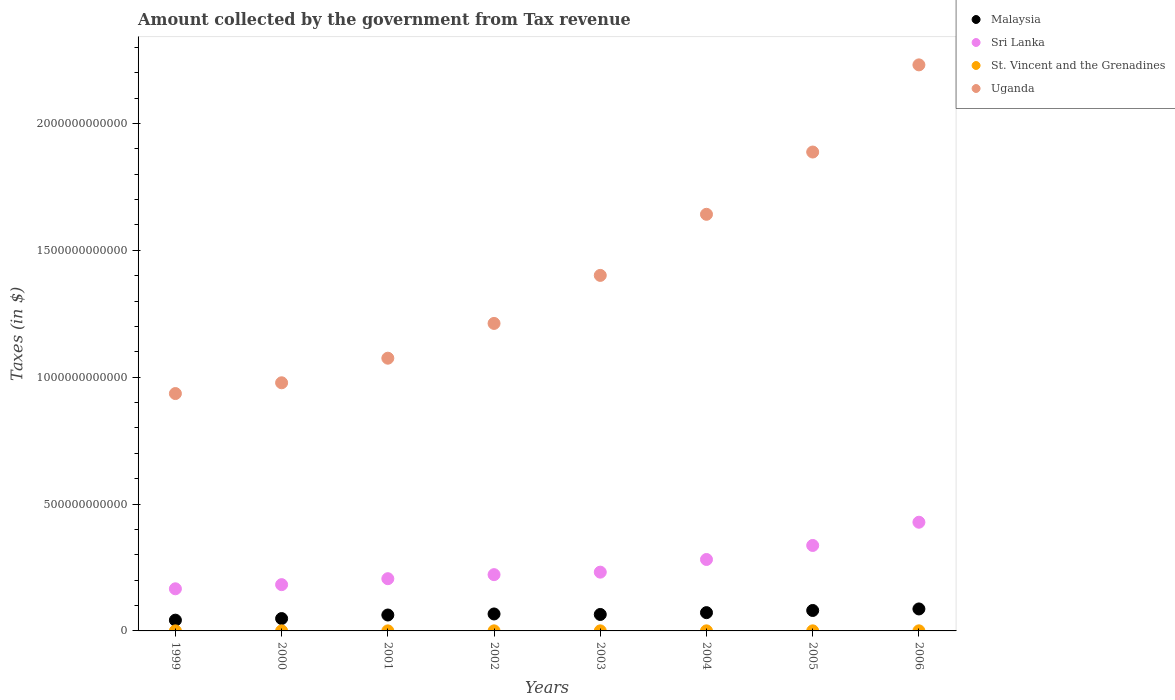What is the amount collected by the government from tax revenue in Uganda in 2006?
Make the answer very short. 2.23e+12. Across all years, what is the maximum amount collected by the government from tax revenue in Sri Lanka?
Your response must be concise. 4.28e+11. Across all years, what is the minimum amount collected by the government from tax revenue in Uganda?
Your answer should be very brief. 9.36e+11. In which year was the amount collected by the government from tax revenue in Uganda maximum?
Offer a very short reply. 2006. In which year was the amount collected by the government from tax revenue in Malaysia minimum?
Keep it short and to the point. 1999. What is the total amount collected by the government from tax revenue in Uganda in the graph?
Make the answer very short. 1.14e+13. What is the difference between the amount collected by the government from tax revenue in Sri Lanka in 1999 and that in 2001?
Provide a succinct answer. -3.98e+1. What is the difference between the amount collected by the government from tax revenue in St. Vincent and the Grenadines in 2006 and the amount collected by the government from tax revenue in Sri Lanka in 2001?
Provide a short and direct response. -2.05e+11. What is the average amount collected by the government from tax revenue in Sri Lanka per year?
Offer a very short reply. 2.57e+11. In the year 2006, what is the difference between the amount collected by the government from tax revenue in St. Vincent and the Grenadines and amount collected by the government from tax revenue in Uganda?
Give a very brief answer. -2.23e+12. What is the ratio of the amount collected by the government from tax revenue in Malaysia in 2002 to that in 2005?
Ensure brevity in your answer.  0.83. Is the amount collected by the government from tax revenue in Sri Lanka in 1999 less than that in 2006?
Offer a very short reply. Yes. What is the difference between the highest and the second highest amount collected by the government from tax revenue in Sri Lanka?
Make the answer very short. 9.16e+1. What is the difference between the highest and the lowest amount collected by the government from tax revenue in Sri Lanka?
Offer a very short reply. 2.62e+11. In how many years, is the amount collected by the government from tax revenue in Uganda greater than the average amount collected by the government from tax revenue in Uganda taken over all years?
Make the answer very short. 3. Is the sum of the amount collected by the government from tax revenue in Uganda in 2001 and 2002 greater than the maximum amount collected by the government from tax revenue in St. Vincent and the Grenadines across all years?
Offer a terse response. Yes. Is it the case that in every year, the sum of the amount collected by the government from tax revenue in Uganda and amount collected by the government from tax revenue in St. Vincent and the Grenadines  is greater than the amount collected by the government from tax revenue in Sri Lanka?
Make the answer very short. Yes. Is the amount collected by the government from tax revenue in St. Vincent and the Grenadines strictly less than the amount collected by the government from tax revenue in Uganda over the years?
Provide a succinct answer. Yes. What is the difference between two consecutive major ticks on the Y-axis?
Keep it short and to the point. 5.00e+11. Are the values on the major ticks of Y-axis written in scientific E-notation?
Provide a succinct answer. No. What is the title of the graph?
Offer a terse response. Amount collected by the government from Tax revenue. What is the label or title of the X-axis?
Provide a short and direct response. Years. What is the label or title of the Y-axis?
Offer a very short reply. Taxes (in $). What is the Taxes (in $) of Malaysia in 1999?
Offer a very short reply. 4.24e+1. What is the Taxes (in $) of Sri Lanka in 1999?
Your answer should be very brief. 1.66e+11. What is the Taxes (in $) of St. Vincent and the Grenadines in 1999?
Your answer should be very brief. 2.18e+08. What is the Taxes (in $) of Uganda in 1999?
Provide a short and direct response. 9.36e+11. What is the Taxes (in $) of Malaysia in 2000?
Provide a short and direct response. 4.87e+1. What is the Taxes (in $) in Sri Lanka in 2000?
Provide a short and direct response. 1.82e+11. What is the Taxes (in $) of St. Vincent and the Grenadines in 2000?
Offer a terse response. 2.28e+08. What is the Taxes (in $) of Uganda in 2000?
Keep it short and to the point. 9.78e+11. What is the Taxes (in $) in Malaysia in 2001?
Your answer should be compact. 6.27e+1. What is the Taxes (in $) of Sri Lanka in 2001?
Give a very brief answer. 2.06e+11. What is the Taxes (in $) of St. Vincent and the Grenadines in 2001?
Provide a short and direct response. 2.42e+08. What is the Taxes (in $) in Uganda in 2001?
Your answer should be compact. 1.07e+12. What is the Taxes (in $) of Malaysia in 2002?
Make the answer very short. 6.69e+1. What is the Taxes (in $) in Sri Lanka in 2002?
Ensure brevity in your answer.  2.22e+11. What is the Taxes (in $) in St. Vincent and the Grenadines in 2002?
Provide a succinct answer. 2.73e+08. What is the Taxes (in $) of Uganda in 2002?
Provide a succinct answer. 1.21e+12. What is the Taxes (in $) of Malaysia in 2003?
Your answer should be very brief. 6.49e+1. What is the Taxes (in $) in Sri Lanka in 2003?
Keep it short and to the point. 2.32e+11. What is the Taxes (in $) of St. Vincent and the Grenadines in 2003?
Provide a short and direct response. 2.72e+08. What is the Taxes (in $) in Uganda in 2003?
Offer a very short reply. 1.40e+12. What is the Taxes (in $) of Malaysia in 2004?
Your answer should be very brief. 7.21e+1. What is the Taxes (in $) in Sri Lanka in 2004?
Provide a succinct answer. 2.82e+11. What is the Taxes (in $) of St. Vincent and the Grenadines in 2004?
Provide a succinct answer. 2.91e+08. What is the Taxes (in $) in Uganda in 2004?
Ensure brevity in your answer.  1.64e+12. What is the Taxes (in $) of Malaysia in 2005?
Provide a succinct answer. 8.06e+1. What is the Taxes (in $) of Sri Lanka in 2005?
Your answer should be compact. 3.37e+11. What is the Taxes (in $) of St. Vincent and the Grenadines in 2005?
Keep it short and to the point. 3.05e+08. What is the Taxes (in $) in Uganda in 2005?
Keep it short and to the point. 1.89e+12. What is the Taxes (in $) of Malaysia in 2006?
Your answer should be very brief. 8.66e+1. What is the Taxes (in $) in Sri Lanka in 2006?
Offer a very short reply. 4.28e+11. What is the Taxes (in $) in St. Vincent and the Grenadines in 2006?
Give a very brief answer. 3.63e+08. What is the Taxes (in $) in Uganda in 2006?
Offer a terse response. 2.23e+12. Across all years, what is the maximum Taxes (in $) of Malaysia?
Offer a very short reply. 8.66e+1. Across all years, what is the maximum Taxes (in $) in Sri Lanka?
Provide a short and direct response. 4.28e+11. Across all years, what is the maximum Taxes (in $) of St. Vincent and the Grenadines?
Your answer should be compact. 3.63e+08. Across all years, what is the maximum Taxes (in $) of Uganda?
Your answer should be very brief. 2.23e+12. Across all years, what is the minimum Taxes (in $) in Malaysia?
Keep it short and to the point. 4.24e+1. Across all years, what is the minimum Taxes (in $) of Sri Lanka?
Keep it short and to the point. 1.66e+11. Across all years, what is the minimum Taxes (in $) of St. Vincent and the Grenadines?
Your answer should be compact. 2.18e+08. Across all years, what is the minimum Taxes (in $) in Uganda?
Your answer should be very brief. 9.36e+11. What is the total Taxes (in $) in Malaysia in the graph?
Your response must be concise. 5.25e+11. What is the total Taxes (in $) of Sri Lanka in the graph?
Offer a terse response. 2.05e+12. What is the total Taxes (in $) of St. Vincent and the Grenadines in the graph?
Offer a terse response. 2.19e+09. What is the total Taxes (in $) of Uganda in the graph?
Your answer should be compact. 1.14e+13. What is the difference between the Taxes (in $) of Malaysia in 1999 and that in 2000?
Keep it short and to the point. -6.32e+09. What is the difference between the Taxes (in $) of Sri Lanka in 1999 and that in 2000?
Your answer should be compact. -1.64e+1. What is the difference between the Taxes (in $) of St. Vincent and the Grenadines in 1999 and that in 2000?
Give a very brief answer. -9.30e+06. What is the difference between the Taxes (in $) in Uganda in 1999 and that in 2000?
Make the answer very short. -4.24e+1. What is the difference between the Taxes (in $) of Malaysia in 1999 and that in 2001?
Offer a terse response. -2.04e+1. What is the difference between the Taxes (in $) of Sri Lanka in 1999 and that in 2001?
Offer a terse response. -3.98e+1. What is the difference between the Taxes (in $) of St. Vincent and the Grenadines in 1999 and that in 2001?
Your answer should be very brief. -2.33e+07. What is the difference between the Taxes (in $) in Uganda in 1999 and that in 2001?
Your answer should be compact. -1.39e+11. What is the difference between the Taxes (in $) in Malaysia in 1999 and that in 2002?
Your response must be concise. -2.45e+1. What is the difference between the Taxes (in $) of Sri Lanka in 1999 and that in 2002?
Ensure brevity in your answer.  -5.58e+1. What is the difference between the Taxes (in $) of St. Vincent and the Grenadines in 1999 and that in 2002?
Provide a short and direct response. -5.45e+07. What is the difference between the Taxes (in $) in Uganda in 1999 and that in 2002?
Offer a very short reply. -2.76e+11. What is the difference between the Taxes (in $) of Malaysia in 1999 and that in 2003?
Your answer should be very brief. -2.25e+1. What is the difference between the Taxes (in $) of Sri Lanka in 1999 and that in 2003?
Ensure brevity in your answer.  -6.56e+1. What is the difference between the Taxes (in $) of St. Vincent and the Grenadines in 1999 and that in 2003?
Give a very brief answer. -5.42e+07. What is the difference between the Taxes (in $) in Uganda in 1999 and that in 2003?
Offer a terse response. -4.66e+11. What is the difference between the Taxes (in $) in Malaysia in 1999 and that in 2004?
Offer a very short reply. -2.97e+1. What is the difference between the Taxes (in $) in Sri Lanka in 1999 and that in 2004?
Offer a very short reply. -1.16e+11. What is the difference between the Taxes (in $) in St. Vincent and the Grenadines in 1999 and that in 2004?
Offer a terse response. -7.26e+07. What is the difference between the Taxes (in $) in Uganda in 1999 and that in 2004?
Give a very brief answer. -7.06e+11. What is the difference between the Taxes (in $) of Malaysia in 1999 and that in 2005?
Keep it short and to the point. -3.82e+1. What is the difference between the Taxes (in $) in Sri Lanka in 1999 and that in 2005?
Your answer should be very brief. -1.71e+11. What is the difference between the Taxes (in $) of St. Vincent and the Grenadines in 1999 and that in 2005?
Provide a succinct answer. -8.70e+07. What is the difference between the Taxes (in $) of Uganda in 1999 and that in 2005?
Give a very brief answer. -9.52e+11. What is the difference between the Taxes (in $) in Malaysia in 1999 and that in 2006?
Provide a succinct answer. -4.42e+1. What is the difference between the Taxes (in $) in Sri Lanka in 1999 and that in 2006?
Offer a terse response. -2.62e+11. What is the difference between the Taxes (in $) of St. Vincent and the Grenadines in 1999 and that in 2006?
Provide a short and direct response. -1.44e+08. What is the difference between the Taxes (in $) of Uganda in 1999 and that in 2006?
Your answer should be very brief. -1.30e+12. What is the difference between the Taxes (in $) in Malaysia in 2000 and that in 2001?
Offer a terse response. -1.40e+1. What is the difference between the Taxes (in $) in Sri Lanka in 2000 and that in 2001?
Keep it short and to the point. -2.34e+1. What is the difference between the Taxes (in $) in St. Vincent and the Grenadines in 2000 and that in 2001?
Provide a short and direct response. -1.40e+07. What is the difference between the Taxes (in $) of Uganda in 2000 and that in 2001?
Your answer should be very brief. -9.69e+1. What is the difference between the Taxes (in $) in Malaysia in 2000 and that in 2002?
Provide a succinct answer. -1.82e+1. What is the difference between the Taxes (in $) in Sri Lanka in 2000 and that in 2002?
Offer a terse response. -3.94e+1. What is the difference between the Taxes (in $) of St. Vincent and the Grenadines in 2000 and that in 2002?
Your answer should be compact. -4.52e+07. What is the difference between the Taxes (in $) of Uganda in 2000 and that in 2002?
Offer a terse response. -2.34e+11. What is the difference between the Taxes (in $) in Malaysia in 2000 and that in 2003?
Make the answer very short. -1.62e+1. What is the difference between the Taxes (in $) of Sri Lanka in 2000 and that in 2003?
Your answer should be very brief. -4.93e+1. What is the difference between the Taxes (in $) of St. Vincent and the Grenadines in 2000 and that in 2003?
Make the answer very short. -4.49e+07. What is the difference between the Taxes (in $) in Uganda in 2000 and that in 2003?
Your answer should be compact. -4.23e+11. What is the difference between the Taxes (in $) of Malaysia in 2000 and that in 2004?
Your answer should be very brief. -2.33e+1. What is the difference between the Taxes (in $) of Sri Lanka in 2000 and that in 2004?
Keep it short and to the point. -9.92e+1. What is the difference between the Taxes (in $) of St. Vincent and the Grenadines in 2000 and that in 2004?
Give a very brief answer. -6.33e+07. What is the difference between the Taxes (in $) of Uganda in 2000 and that in 2004?
Your answer should be compact. -6.64e+11. What is the difference between the Taxes (in $) in Malaysia in 2000 and that in 2005?
Ensure brevity in your answer.  -3.19e+1. What is the difference between the Taxes (in $) in Sri Lanka in 2000 and that in 2005?
Keep it short and to the point. -1.54e+11. What is the difference between the Taxes (in $) of St. Vincent and the Grenadines in 2000 and that in 2005?
Your response must be concise. -7.77e+07. What is the difference between the Taxes (in $) of Uganda in 2000 and that in 2005?
Offer a very short reply. -9.09e+11. What is the difference between the Taxes (in $) of Malaysia in 2000 and that in 2006?
Give a very brief answer. -3.79e+1. What is the difference between the Taxes (in $) in Sri Lanka in 2000 and that in 2006?
Ensure brevity in your answer.  -2.46e+11. What is the difference between the Taxes (in $) in St. Vincent and the Grenadines in 2000 and that in 2006?
Offer a terse response. -1.35e+08. What is the difference between the Taxes (in $) of Uganda in 2000 and that in 2006?
Give a very brief answer. -1.25e+12. What is the difference between the Taxes (in $) of Malaysia in 2001 and that in 2002?
Provide a short and direct response. -4.12e+09. What is the difference between the Taxes (in $) of Sri Lanka in 2001 and that in 2002?
Offer a terse response. -1.59e+1. What is the difference between the Taxes (in $) in St. Vincent and the Grenadines in 2001 and that in 2002?
Ensure brevity in your answer.  -3.12e+07. What is the difference between the Taxes (in $) in Uganda in 2001 and that in 2002?
Your response must be concise. -1.37e+11. What is the difference between the Taxes (in $) in Malaysia in 2001 and that in 2003?
Make the answer very short. -2.15e+09. What is the difference between the Taxes (in $) in Sri Lanka in 2001 and that in 2003?
Keep it short and to the point. -2.58e+1. What is the difference between the Taxes (in $) in St. Vincent and the Grenadines in 2001 and that in 2003?
Keep it short and to the point. -3.09e+07. What is the difference between the Taxes (in $) in Uganda in 2001 and that in 2003?
Keep it short and to the point. -3.26e+11. What is the difference between the Taxes (in $) in Malaysia in 2001 and that in 2004?
Provide a short and direct response. -9.31e+09. What is the difference between the Taxes (in $) of Sri Lanka in 2001 and that in 2004?
Provide a succinct answer. -7.57e+1. What is the difference between the Taxes (in $) of St. Vincent and the Grenadines in 2001 and that in 2004?
Your answer should be very brief. -4.93e+07. What is the difference between the Taxes (in $) in Uganda in 2001 and that in 2004?
Offer a terse response. -5.67e+11. What is the difference between the Taxes (in $) of Malaysia in 2001 and that in 2005?
Ensure brevity in your answer.  -1.79e+1. What is the difference between the Taxes (in $) of Sri Lanka in 2001 and that in 2005?
Provide a succinct answer. -1.31e+11. What is the difference between the Taxes (in $) in St. Vincent and the Grenadines in 2001 and that in 2005?
Your response must be concise. -6.37e+07. What is the difference between the Taxes (in $) in Uganda in 2001 and that in 2005?
Offer a terse response. -8.13e+11. What is the difference between the Taxes (in $) in Malaysia in 2001 and that in 2006?
Your response must be concise. -2.39e+1. What is the difference between the Taxes (in $) in Sri Lanka in 2001 and that in 2006?
Offer a very short reply. -2.23e+11. What is the difference between the Taxes (in $) in St. Vincent and the Grenadines in 2001 and that in 2006?
Provide a succinct answer. -1.21e+08. What is the difference between the Taxes (in $) in Uganda in 2001 and that in 2006?
Offer a terse response. -1.16e+12. What is the difference between the Taxes (in $) of Malaysia in 2002 and that in 2003?
Provide a short and direct response. 1.97e+09. What is the difference between the Taxes (in $) of Sri Lanka in 2002 and that in 2003?
Give a very brief answer. -9.86e+09. What is the difference between the Taxes (in $) in St. Vincent and the Grenadines in 2002 and that in 2003?
Ensure brevity in your answer.  3.00e+05. What is the difference between the Taxes (in $) of Uganda in 2002 and that in 2003?
Make the answer very short. -1.89e+11. What is the difference between the Taxes (in $) in Malaysia in 2002 and that in 2004?
Give a very brief answer. -5.19e+09. What is the difference between the Taxes (in $) of Sri Lanka in 2002 and that in 2004?
Your answer should be compact. -5.98e+1. What is the difference between the Taxes (in $) of St. Vincent and the Grenadines in 2002 and that in 2004?
Provide a succinct answer. -1.81e+07. What is the difference between the Taxes (in $) in Uganda in 2002 and that in 2004?
Offer a very short reply. -4.30e+11. What is the difference between the Taxes (in $) of Malaysia in 2002 and that in 2005?
Ensure brevity in your answer.  -1.37e+1. What is the difference between the Taxes (in $) of Sri Lanka in 2002 and that in 2005?
Make the answer very short. -1.15e+11. What is the difference between the Taxes (in $) of St. Vincent and the Grenadines in 2002 and that in 2005?
Keep it short and to the point. -3.25e+07. What is the difference between the Taxes (in $) in Uganda in 2002 and that in 2005?
Your answer should be compact. -6.75e+11. What is the difference between the Taxes (in $) in Malaysia in 2002 and that in 2006?
Keep it short and to the point. -1.98e+1. What is the difference between the Taxes (in $) of Sri Lanka in 2002 and that in 2006?
Make the answer very short. -2.07e+11. What is the difference between the Taxes (in $) in St. Vincent and the Grenadines in 2002 and that in 2006?
Offer a very short reply. -9.00e+07. What is the difference between the Taxes (in $) of Uganda in 2002 and that in 2006?
Offer a very short reply. -1.02e+12. What is the difference between the Taxes (in $) in Malaysia in 2003 and that in 2004?
Give a very brief answer. -7.16e+09. What is the difference between the Taxes (in $) in Sri Lanka in 2003 and that in 2004?
Ensure brevity in your answer.  -4.99e+1. What is the difference between the Taxes (in $) of St. Vincent and the Grenadines in 2003 and that in 2004?
Offer a very short reply. -1.84e+07. What is the difference between the Taxes (in $) of Uganda in 2003 and that in 2004?
Keep it short and to the point. -2.41e+11. What is the difference between the Taxes (in $) in Malaysia in 2003 and that in 2005?
Make the answer very short. -1.57e+1. What is the difference between the Taxes (in $) in Sri Lanka in 2003 and that in 2005?
Offer a terse response. -1.05e+11. What is the difference between the Taxes (in $) of St. Vincent and the Grenadines in 2003 and that in 2005?
Provide a short and direct response. -3.28e+07. What is the difference between the Taxes (in $) in Uganda in 2003 and that in 2005?
Offer a very short reply. -4.86e+11. What is the difference between the Taxes (in $) in Malaysia in 2003 and that in 2006?
Offer a terse response. -2.17e+1. What is the difference between the Taxes (in $) in Sri Lanka in 2003 and that in 2006?
Give a very brief answer. -1.97e+11. What is the difference between the Taxes (in $) in St. Vincent and the Grenadines in 2003 and that in 2006?
Keep it short and to the point. -9.03e+07. What is the difference between the Taxes (in $) of Uganda in 2003 and that in 2006?
Offer a terse response. -8.30e+11. What is the difference between the Taxes (in $) of Malaysia in 2004 and that in 2005?
Your answer should be very brief. -8.54e+09. What is the difference between the Taxes (in $) of Sri Lanka in 2004 and that in 2005?
Keep it short and to the point. -5.53e+1. What is the difference between the Taxes (in $) in St. Vincent and the Grenadines in 2004 and that in 2005?
Provide a short and direct response. -1.44e+07. What is the difference between the Taxes (in $) of Uganda in 2004 and that in 2005?
Give a very brief answer. -2.45e+11. What is the difference between the Taxes (in $) of Malaysia in 2004 and that in 2006?
Provide a short and direct response. -1.46e+1. What is the difference between the Taxes (in $) of Sri Lanka in 2004 and that in 2006?
Ensure brevity in your answer.  -1.47e+11. What is the difference between the Taxes (in $) in St. Vincent and the Grenadines in 2004 and that in 2006?
Offer a terse response. -7.19e+07. What is the difference between the Taxes (in $) of Uganda in 2004 and that in 2006?
Your response must be concise. -5.89e+11. What is the difference between the Taxes (in $) in Malaysia in 2005 and that in 2006?
Provide a succinct answer. -6.04e+09. What is the difference between the Taxes (in $) in Sri Lanka in 2005 and that in 2006?
Keep it short and to the point. -9.16e+1. What is the difference between the Taxes (in $) of St. Vincent and the Grenadines in 2005 and that in 2006?
Your answer should be compact. -5.75e+07. What is the difference between the Taxes (in $) of Uganda in 2005 and that in 2006?
Ensure brevity in your answer.  -3.44e+11. What is the difference between the Taxes (in $) of Malaysia in 1999 and the Taxes (in $) of Sri Lanka in 2000?
Give a very brief answer. -1.40e+11. What is the difference between the Taxes (in $) in Malaysia in 1999 and the Taxes (in $) in St. Vincent and the Grenadines in 2000?
Make the answer very short. 4.22e+1. What is the difference between the Taxes (in $) of Malaysia in 1999 and the Taxes (in $) of Uganda in 2000?
Your answer should be very brief. -9.36e+11. What is the difference between the Taxes (in $) of Sri Lanka in 1999 and the Taxes (in $) of St. Vincent and the Grenadines in 2000?
Keep it short and to the point. 1.66e+11. What is the difference between the Taxes (in $) in Sri Lanka in 1999 and the Taxes (in $) in Uganda in 2000?
Your response must be concise. -8.12e+11. What is the difference between the Taxes (in $) of St. Vincent and the Grenadines in 1999 and the Taxes (in $) of Uganda in 2000?
Offer a terse response. -9.78e+11. What is the difference between the Taxes (in $) of Malaysia in 1999 and the Taxes (in $) of Sri Lanka in 2001?
Your response must be concise. -1.63e+11. What is the difference between the Taxes (in $) of Malaysia in 1999 and the Taxes (in $) of St. Vincent and the Grenadines in 2001?
Provide a succinct answer. 4.21e+1. What is the difference between the Taxes (in $) in Malaysia in 1999 and the Taxes (in $) in Uganda in 2001?
Make the answer very short. -1.03e+12. What is the difference between the Taxes (in $) of Sri Lanka in 1999 and the Taxes (in $) of St. Vincent and the Grenadines in 2001?
Offer a very short reply. 1.66e+11. What is the difference between the Taxes (in $) in Sri Lanka in 1999 and the Taxes (in $) in Uganda in 2001?
Your answer should be very brief. -9.09e+11. What is the difference between the Taxes (in $) in St. Vincent and the Grenadines in 1999 and the Taxes (in $) in Uganda in 2001?
Your answer should be very brief. -1.07e+12. What is the difference between the Taxes (in $) of Malaysia in 1999 and the Taxes (in $) of Sri Lanka in 2002?
Ensure brevity in your answer.  -1.79e+11. What is the difference between the Taxes (in $) in Malaysia in 1999 and the Taxes (in $) in St. Vincent and the Grenadines in 2002?
Ensure brevity in your answer.  4.21e+1. What is the difference between the Taxes (in $) in Malaysia in 1999 and the Taxes (in $) in Uganda in 2002?
Offer a terse response. -1.17e+12. What is the difference between the Taxes (in $) in Sri Lanka in 1999 and the Taxes (in $) in St. Vincent and the Grenadines in 2002?
Your response must be concise. 1.66e+11. What is the difference between the Taxes (in $) in Sri Lanka in 1999 and the Taxes (in $) in Uganda in 2002?
Make the answer very short. -1.05e+12. What is the difference between the Taxes (in $) in St. Vincent and the Grenadines in 1999 and the Taxes (in $) in Uganda in 2002?
Offer a terse response. -1.21e+12. What is the difference between the Taxes (in $) of Malaysia in 1999 and the Taxes (in $) of Sri Lanka in 2003?
Offer a very short reply. -1.89e+11. What is the difference between the Taxes (in $) of Malaysia in 1999 and the Taxes (in $) of St. Vincent and the Grenadines in 2003?
Offer a terse response. 4.21e+1. What is the difference between the Taxes (in $) in Malaysia in 1999 and the Taxes (in $) in Uganda in 2003?
Keep it short and to the point. -1.36e+12. What is the difference between the Taxes (in $) of Sri Lanka in 1999 and the Taxes (in $) of St. Vincent and the Grenadines in 2003?
Provide a succinct answer. 1.66e+11. What is the difference between the Taxes (in $) of Sri Lanka in 1999 and the Taxes (in $) of Uganda in 2003?
Your response must be concise. -1.24e+12. What is the difference between the Taxes (in $) of St. Vincent and the Grenadines in 1999 and the Taxes (in $) of Uganda in 2003?
Offer a terse response. -1.40e+12. What is the difference between the Taxes (in $) of Malaysia in 1999 and the Taxes (in $) of Sri Lanka in 2004?
Make the answer very short. -2.39e+11. What is the difference between the Taxes (in $) of Malaysia in 1999 and the Taxes (in $) of St. Vincent and the Grenadines in 2004?
Offer a very short reply. 4.21e+1. What is the difference between the Taxes (in $) in Malaysia in 1999 and the Taxes (in $) in Uganda in 2004?
Ensure brevity in your answer.  -1.60e+12. What is the difference between the Taxes (in $) in Sri Lanka in 1999 and the Taxes (in $) in St. Vincent and the Grenadines in 2004?
Your response must be concise. 1.66e+11. What is the difference between the Taxes (in $) of Sri Lanka in 1999 and the Taxes (in $) of Uganda in 2004?
Your answer should be compact. -1.48e+12. What is the difference between the Taxes (in $) in St. Vincent and the Grenadines in 1999 and the Taxes (in $) in Uganda in 2004?
Your answer should be very brief. -1.64e+12. What is the difference between the Taxes (in $) in Malaysia in 1999 and the Taxes (in $) in Sri Lanka in 2005?
Your answer should be compact. -2.94e+11. What is the difference between the Taxes (in $) of Malaysia in 1999 and the Taxes (in $) of St. Vincent and the Grenadines in 2005?
Give a very brief answer. 4.21e+1. What is the difference between the Taxes (in $) in Malaysia in 1999 and the Taxes (in $) in Uganda in 2005?
Keep it short and to the point. -1.85e+12. What is the difference between the Taxes (in $) in Sri Lanka in 1999 and the Taxes (in $) in St. Vincent and the Grenadines in 2005?
Make the answer very short. 1.66e+11. What is the difference between the Taxes (in $) in Sri Lanka in 1999 and the Taxes (in $) in Uganda in 2005?
Your answer should be compact. -1.72e+12. What is the difference between the Taxes (in $) of St. Vincent and the Grenadines in 1999 and the Taxes (in $) of Uganda in 2005?
Your answer should be very brief. -1.89e+12. What is the difference between the Taxes (in $) of Malaysia in 1999 and the Taxes (in $) of Sri Lanka in 2006?
Offer a terse response. -3.86e+11. What is the difference between the Taxes (in $) of Malaysia in 1999 and the Taxes (in $) of St. Vincent and the Grenadines in 2006?
Provide a succinct answer. 4.20e+1. What is the difference between the Taxes (in $) in Malaysia in 1999 and the Taxes (in $) in Uganda in 2006?
Your answer should be compact. -2.19e+12. What is the difference between the Taxes (in $) in Sri Lanka in 1999 and the Taxes (in $) in St. Vincent and the Grenadines in 2006?
Your answer should be very brief. 1.66e+11. What is the difference between the Taxes (in $) in Sri Lanka in 1999 and the Taxes (in $) in Uganda in 2006?
Make the answer very short. -2.06e+12. What is the difference between the Taxes (in $) of St. Vincent and the Grenadines in 1999 and the Taxes (in $) of Uganda in 2006?
Provide a succinct answer. -2.23e+12. What is the difference between the Taxes (in $) of Malaysia in 2000 and the Taxes (in $) of Sri Lanka in 2001?
Your answer should be compact. -1.57e+11. What is the difference between the Taxes (in $) in Malaysia in 2000 and the Taxes (in $) in St. Vincent and the Grenadines in 2001?
Provide a succinct answer. 4.85e+1. What is the difference between the Taxes (in $) in Malaysia in 2000 and the Taxes (in $) in Uganda in 2001?
Your response must be concise. -1.03e+12. What is the difference between the Taxes (in $) in Sri Lanka in 2000 and the Taxes (in $) in St. Vincent and the Grenadines in 2001?
Provide a succinct answer. 1.82e+11. What is the difference between the Taxes (in $) in Sri Lanka in 2000 and the Taxes (in $) in Uganda in 2001?
Give a very brief answer. -8.93e+11. What is the difference between the Taxes (in $) in St. Vincent and the Grenadines in 2000 and the Taxes (in $) in Uganda in 2001?
Your answer should be compact. -1.07e+12. What is the difference between the Taxes (in $) in Malaysia in 2000 and the Taxes (in $) in Sri Lanka in 2002?
Your answer should be very brief. -1.73e+11. What is the difference between the Taxes (in $) in Malaysia in 2000 and the Taxes (in $) in St. Vincent and the Grenadines in 2002?
Keep it short and to the point. 4.84e+1. What is the difference between the Taxes (in $) in Malaysia in 2000 and the Taxes (in $) in Uganda in 2002?
Give a very brief answer. -1.16e+12. What is the difference between the Taxes (in $) of Sri Lanka in 2000 and the Taxes (in $) of St. Vincent and the Grenadines in 2002?
Offer a very short reply. 1.82e+11. What is the difference between the Taxes (in $) in Sri Lanka in 2000 and the Taxes (in $) in Uganda in 2002?
Offer a terse response. -1.03e+12. What is the difference between the Taxes (in $) in St. Vincent and the Grenadines in 2000 and the Taxes (in $) in Uganda in 2002?
Offer a very short reply. -1.21e+12. What is the difference between the Taxes (in $) in Malaysia in 2000 and the Taxes (in $) in Sri Lanka in 2003?
Ensure brevity in your answer.  -1.83e+11. What is the difference between the Taxes (in $) of Malaysia in 2000 and the Taxes (in $) of St. Vincent and the Grenadines in 2003?
Offer a terse response. 4.84e+1. What is the difference between the Taxes (in $) in Malaysia in 2000 and the Taxes (in $) in Uganda in 2003?
Your answer should be compact. -1.35e+12. What is the difference between the Taxes (in $) in Sri Lanka in 2000 and the Taxes (in $) in St. Vincent and the Grenadines in 2003?
Your answer should be compact. 1.82e+11. What is the difference between the Taxes (in $) in Sri Lanka in 2000 and the Taxes (in $) in Uganda in 2003?
Your answer should be compact. -1.22e+12. What is the difference between the Taxes (in $) in St. Vincent and the Grenadines in 2000 and the Taxes (in $) in Uganda in 2003?
Your answer should be very brief. -1.40e+12. What is the difference between the Taxes (in $) of Malaysia in 2000 and the Taxes (in $) of Sri Lanka in 2004?
Ensure brevity in your answer.  -2.33e+11. What is the difference between the Taxes (in $) of Malaysia in 2000 and the Taxes (in $) of St. Vincent and the Grenadines in 2004?
Provide a succinct answer. 4.84e+1. What is the difference between the Taxes (in $) of Malaysia in 2000 and the Taxes (in $) of Uganda in 2004?
Offer a terse response. -1.59e+12. What is the difference between the Taxes (in $) of Sri Lanka in 2000 and the Taxes (in $) of St. Vincent and the Grenadines in 2004?
Your answer should be very brief. 1.82e+11. What is the difference between the Taxes (in $) of Sri Lanka in 2000 and the Taxes (in $) of Uganda in 2004?
Give a very brief answer. -1.46e+12. What is the difference between the Taxes (in $) of St. Vincent and the Grenadines in 2000 and the Taxes (in $) of Uganda in 2004?
Your answer should be compact. -1.64e+12. What is the difference between the Taxes (in $) of Malaysia in 2000 and the Taxes (in $) of Sri Lanka in 2005?
Offer a very short reply. -2.88e+11. What is the difference between the Taxes (in $) of Malaysia in 2000 and the Taxes (in $) of St. Vincent and the Grenadines in 2005?
Your answer should be very brief. 4.84e+1. What is the difference between the Taxes (in $) in Malaysia in 2000 and the Taxes (in $) in Uganda in 2005?
Provide a succinct answer. -1.84e+12. What is the difference between the Taxes (in $) in Sri Lanka in 2000 and the Taxes (in $) in St. Vincent and the Grenadines in 2005?
Give a very brief answer. 1.82e+11. What is the difference between the Taxes (in $) in Sri Lanka in 2000 and the Taxes (in $) in Uganda in 2005?
Ensure brevity in your answer.  -1.71e+12. What is the difference between the Taxes (in $) of St. Vincent and the Grenadines in 2000 and the Taxes (in $) of Uganda in 2005?
Provide a succinct answer. -1.89e+12. What is the difference between the Taxes (in $) of Malaysia in 2000 and the Taxes (in $) of Sri Lanka in 2006?
Your answer should be compact. -3.80e+11. What is the difference between the Taxes (in $) of Malaysia in 2000 and the Taxes (in $) of St. Vincent and the Grenadines in 2006?
Make the answer very short. 4.83e+1. What is the difference between the Taxes (in $) of Malaysia in 2000 and the Taxes (in $) of Uganda in 2006?
Ensure brevity in your answer.  -2.18e+12. What is the difference between the Taxes (in $) in Sri Lanka in 2000 and the Taxes (in $) in St. Vincent and the Grenadines in 2006?
Provide a short and direct response. 1.82e+11. What is the difference between the Taxes (in $) of Sri Lanka in 2000 and the Taxes (in $) of Uganda in 2006?
Give a very brief answer. -2.05e+12. What is the difference between the Taxes (in $) in St. Vincent and the Grenadines in 2000 and the Taxes (in $) in Uganda in 2006?
Ensure brevity in your answer.  -2.23e+12. What is the difference between the Taxes (in $) of Malaysia in 2001 and the Taxes (in $) of Sri Lanka in 2002?
Make the answer very short. -1.59e+11. What is the difference between the Taxes (in $) of Malaysia in 2001 and the Taxes (in $) of St. Vincent and the Grenadines in 2002?
Make the answer very short. 6.25e+1. What is the difference between the Taxes (in $) of Malaysia in 2001 and the Taxes (in $) of Uganda in 2002?
Ensure brevity in your answer.  -1.15e+12. What is the difference between the Taxes (in $) of Sri Lanka in 2001 and the Taxes (in $) of St. Vincent and the Grenadines in 2002?
Keep it short and to the point. 2.06e+11. What is the difference between the Taxes (in $) of Sri Lanka in 2001 and the Taxes (in $) of Uganda in 2002?
Your answer should be compact. -1.01e+12. What is the difference between the Taxes (in $) of St. Vincent and the Grenadines in 2001 and the Taxes (in $) of Uganda in 2002?
Offer a very short reply. -1.21e+12. What is the difference between the Taxes (in $) of Malaysia in 2001 and the Taxes (in $) of Sri Lanka in 2003?
Provide a succinct answer. -1.69e+11. What is the difference between the Taxes (in $) in Malaysia in 2001 and the Taxes (in $) in St. Vincent and the Grenadines in 2003?
Provide a succinct answer. 6.25e+1. What is the difference between the Taxes (in $) in Malaysia in 2001 and the Taxes (in $) in Uganda in 2003?
Ensure brevity in your answer.  -1.34e+12. What is the difference between the Taxes (in $) in Sri Lanka in 2001 and the Taxes (in $) in St. Vincent and the Grenadines in 2003?
Make the answer very short. 2.06e+11. What is the difference between the Taxes (in $) of Sri Lanka in 2001 and the Taxes (in $) of Uganda in 2003?
Ensure brevity in your answer.  -1.20e+12. What is the difference between the Taxes (in $) in St. Vincent and the Grenadines in 2001 and the Taxes (in $) in Uganda in 2003?
Make the answer very short. -1.40e+12. What is the difference between the Taxes (in $) in Malaysia in 2001 and the Taxes (in $) in Sri Lanka in 2004?
Your answer should be very brief. -2.19e+11. What is the difference between the Taxes (in $) of Malaysia in 2001 and the Taxes (in $) of St. Vincent and the Grenadines in 2004?
Ensure brevity in your answer.  6.25e+1. What is the difference between the Taxes (in $) of Malaysia in 2001 and the Taxes (in $) of Uganda in 2004?
Offer a terse response. -1.58e+12. What is the difference between the Taxes (in $) of Sri Lanka in 2001 and the Taxes (in $) of St. Vincent and the Grenadines in 2004?
Provide a short and direct response. 2.06e+11. What is the difference between the Taxes (in $) in Sri Lanka in 2001 and the Taxes (in $) in Uganda in 2004?
Your answer should be very brief. -1.44e+12. What is the difference between the Taxes (in $) of St. Vincent and the Grenadines in 2001 and the Taxes (in $) of Uganda in 2004?
Provide a short and direct response. -1.64e+12. What is the difference between the Taxes (in $) in Malaysia in 2001 and the Taxes (in $) in Sri Lanka in 2005?
Your answer should be compact. -2.74e+11. What is the difference between the Taxes (in $) in Malaysia in 2001 and the Taxes (in $) in St. Vincent and the Grenadines in 2005?
Provide a succinct answer. 6.24e+1. What is the difference between the Taxes (in $) of Malaysia in 2001 and the Taxes (in $) of Uganda in 2005?
Provide a short and direct response. -1.82e+12. What is the difference between the Taxes (in $) of Sri Lanka in 2001 and the Taxes (in $) of St. Vincent and the Grenadines in 2005?
Make the answer very short. 2.06e+11. What is the difference between the Taxes (in $) in Sri Lanka in 2001 and the Taxes (in $) in Uganda in 2005?
Ensure brevity in your answer.  -1.68e+12. What is the difference between the Taxes (in $) of St. Vincent and the Grenadines in 2001 and the Taxes (in $) of Uganda in 2005?
Your answer should be very brief. -1.89e+12. What is the difference between the Taxes (in $) in Malaysia in 2001 and the Taxes (in $) in Sri Lanka in 2006?
Your answer should be compact. -3.66e+11. What is the difference between the Taxes (in $) of Malaysia in 2001 and the Taxes (in $) of St. Vincent and the Grenadines in 2006?
Give a very brief answer. 6.24e+1. What is the difference between the Taxes (in $) of Malaysia in 2001 and the Taxes (in $) of Uganda in 2006?
Ensure brevity in your answer.  -2.17e+12. What is the difference between the Taxes (in $) of Sri Lanka in 2001 and the Taxes (in $) of St. Vincent and the Grenadines in 2006?
Offer a very short reply. 2.05e+11. What is the difference between the Taxes (in $) of Sri Lanka in 2001 and the Taxes (in $) of Uganda in 2006?
Your response must be concise. -2.03e+12. What is the difference between the Taxes (in $) of St. Vincent and the Grenadines in 2001 and the Taxes (in $) of Uganda in 2006?
Your response must be concise. -2.23e+12. What is the difference between the Taxes (in $) of Malaysia in 2002 and the Taxes (in $) of Sri Lanka in 2003?
Make the answer very short. -1.65e+11. What is the difference between the Taxes (in $) in Malaysia in 2002 and the Taxes (in $) in St. Vincent and the Grenadines in 2003?
Provide a short and direct response. 6.66e+1. What is the difference between the Taxes (in $) of Malaysia in 2002 and the Taxes (in $) of Uganda in 2003?
Make the answer very short. -1.33e+12. What is the difference between the Taxes (in $) of Sri Lanka in 2002 and the Taxes (in $) of St. Vincent and the Grenadines in 2003?
Offer a terse response. 2.22e+11. What is the difference between the Taxes (in $) in Sri Lanka in 2002 and the Taxes (in $) in Uganda in 2003?
Give a very brief answer. -1.18e+12. What is the difference between the Taxes (in $) in St. Vincent and the Grenadines in 2002 and the Taxes (in $) in Uganda in 2003?
Provide a short and direct response. -1.40e+12. What is the difference between the Taxes (in $) of Malaysia in 2002 and the Taxes (in $) of Sri Lanka in 2004?
Provide a succinct answer. -2.15e+11. What is the difference between the Taxes (in $) in Malaysia in 2002 and the Taxes (in $) in St. Vincent and the Grenadines in 2004?
Your response must be concise. 6.66e+1. What is the difference between the Taxes (in $) in Malaysia in 2002 and the Taxes (in $) in Uganda in 2004?
Provide a succinct answer. -1.58e+12. What is the difference between the Taxes (in $) in Sri Lanka in 2002 and the Taxes (in $) in St. Vincent and the Grenadines in 2004?
Make the answer very short. 2.21e+11. What is the difference between the Taxes (in $) of Sri Lanka in 2002 and the Taxes (in $) of Uganda in 2004?
Give a very brief answer. -1.42e+12. What is the difference between the Taxes (in $) of St. Vincent and the Grenadines in 2002 and the Taxes (in $) of Uganda in 2004?
Make the answer very short. -1.64e+12. What is the difference between the Taxes (in $) of Malaysia in 2002 and the Taxes (in $) of Sri Lanka in 2005?
Give a very brief answer. -2.70e+11. What is the difference between the Taxes (in $) of Malaysia in 2002 and the Taxes (in $) of St. Vincent and the Grenadines in 2005?
Make the answer very short. 6.66e+1. What is the difference between the Taxes (in $) of Malaysia in 2002 and the Taxes (in $) of Uganda in 2005?
Keep it short and to the point. -1.82e+12. What is the difference between the Taxes (in $) in Sri Lanka in 2002 and the Taxes (in $) in St. Vincent and the Grenadines in 2005?
Your response must be concise. 2.21e+11. What is the difference between the Taxes (in $) of Sri Lanka in 2002 and the Taxes (in $) of Uganda in 2005?
Ensure brevity in your answer.  -1.67e+12. What is the difference between the Taxes (in $) of St. Vincent and the Grenadines in 2002 and the Taxes (in $) of Uganda in 2005?
Your answer should be very brief. -1.89e+12. What is the difference between the Taxes (in $) in Malaysia in 2002 and the Taxes (in $) in Sri Lanka in 2006?
Provide a succinct answer. -3.62e+11. What is the difference between the Taxes (in $) in Malaysia in 2002 and the Taxes (in $) in St. Vincent and the Grenadines in 2006?
Your response must be concise. 6.65e+1. What is the difference between the Taxes (in $) of Malaysia in 2002 and the Taxes (in $) of Uganda in 2006?
Give a very brief answer. -2.16e+12. What is the difference between the Taxes (in $) of Sri Lanka in 2002 and the Taxes (in $) of St. Vincent and the Grenadines in 2006?
Offer a very short reply. 2.21e+11. What is the difference between the Taxes (in $) in Sri Lanka in 2002 and the Taxes (in $) in Uganda in 2006?
Provide a short and direct response. -2.01e+12. What is the difference between the Taxes (in $) of St. Vincent and the Grenadines in 2002 and the Taxes (in $) of Uganda in 2006?
Keep it short and to the point. -2.23e+12. What is the difference between the Taxes (in $) in Malaysia in 2003 and the Taxes (in $) in Sri Lanka in 2004?
Offer a very short reply. -2.17e+11. What is the difference between the Taxes (in $) of Malaysia in 2003 and the Taxes (in $) of St. Vincent and the Grenadines in 2004?
Make the answer very short. 6.46e+1. What is the difference between the Taxes (in $) of Malaysia in 2003 and the Taxes (in $) of Uganda in 2004?
Provide a short and direct response. -1.58e+12. What is the difference between the Taxes (in $) of Sri Lanka in 2003 and the Taxes (in $) of St. Vincent and the Grenadines in 2004?
Make the answer very short. 2.31e+11. What is the difference between the Taxes (in $) of Sri Lanka in 2003 and the Taxes (in $) of Uganda in 2004?
Offer a terse response. -1.41e+12. What is the difference between the Taxes (in $) of St. Vincent and the Grenadines in 2003 and the Taxes (in $) of Uganda in 2004?
Ensure brevity in your answer.  -1.64e+12. What is the difference between the Taxes (in $) in Malaysia in 2003 and the Taxes (in $) in Sri Lanka in 2005?
Offer a very short reply. -2.72e+11. What is the difference between the Taxes (in $) in Malaysia in 2003 and the Taxes (in $) in St. Vincent and the Grenadines in 2005?
Ensure brevity in your answer.  6.46e+1. What is the difference between the Taxes (in $) in Malaysia in 2003 and the Taxes (in $) in Uganda in 2005?
Ensure brevity in your answer.  -1.82e+12. What is the difference between the Taxes (in $) in Sri Lanka in 2003 and the Taxes (in $) in St. Vincent and the Grenadines in 2005?
Make the answer very short. 2.31e+11. What is the difference between the Taxes (in $) of Sri Lanka in 2003 and the Taxes (in $) of Uganda in 2005?
Your answer should be very brief. -1.66e+12. What is the difference between the Taxes (in $) of St. Vincent and the Grenadines in 2003 and the Taxes (in $) of Uganda in 2005?
Your answer should be very brief. -1.89e+12. What is the difference between the Taxes (in $) in Malaysia in 2003 and the Taxes (in $) in Sri Lanka in 2006?
Offer a terse response. -3.63e+11. What is the difference between the Taxes (in $) of Malaysia in 2003 and the Taxes (in $) of St. Vincent and the Grenadines in 2006?
Offer a terse response. 6.45e+1. What is the difference between the Taxes (in $) of Malaysia in 2003 and the Taxes (in $) of Uganda in 2006?
Keep it short and to the point. -2.17e+12. What is the difference between the Taxes (in $) of Sri Lanka in 2003 and the Taxes (in $) of St. Vincent and the Grenadines in 2006?
Make the answer very short. 2.31e+11. What is the difference between the Taxes (in $) in Sri Lanka in 2003 and the Taxes (in $) in Uganda in 2006?
Ensure brevity in your answer.  -2.00e+12. What is the difference between the Taxes (in $) of St. Vincent and the Grenadines in 2003 and the Taxes (in $) of Uganda in 2006?
Give a very brief answer. -2.23e+12. What is the difference between the Taxes (in $) of Malaysia in 2004 and the Taxes (in $) of Sri Lanka in 2005?
Give a very brief answer. -2.65e+11. What is the difference between the Taxes (in $) of Malaysia in 2004 and the Taxes (in $) of St. Vincent and the Grenadines in 2005?
Provide a short and direct response. 7.17e+1. What is the difference between the Taxes (in $) in Malaysia in 2004 and the Taxes (in $) in Uganda in 2005?
Your answer should be compact. -1.82e+12. What is the difference between the Taxes (in $) in Sri Lanka in 2004 and the Taxes (in $) in St. Vincent and the Grenadines in 2005?
Your response must be concise. 2.81e+11. What is the difference between the Taxes (in $) of Sri Lanka in 2004 and the Taxes (in $) of Uganda in 2005?
Offer a very short reply. -1.61e+12. What is the difference between the Taxes (in $) of St. Vincent and the Grenadines in 2004 and the Taxes (in $) of Uganda in 2005?
Give a very brief answer. -1.89e+12. What is the difference between the Taxes (in $) in Malaysia in 2004 and the Taxes (in $) in Sri Lanka in 2006?
Offer a very short reply. -3.56e+11. What is the difference between the Taxes (in $) in Malaysia in 2004 and the Taxes (in $) in St. Vincent and the Grenadines in 2006?
Offer a terse response. 7.17e+1. What is the difference between the Taxes (in $) of Malaysia in 2004 and the Taxes (in $) of Uganda in 2006?
Provide a succinct answer. -2.16e+12. What is the difference between the Taxes (in $) of Sri Lanka in 2004 and the Taxes (in $) of St. Vincent and the Grenadines in 2006?
Offer a terse response. 2.81e+11. What is the difference between the Taxes (in $) of Sri Lanka in 2004 and the Taxes (in $) of Uganda in 2006?
Offer a terse response. -1.95e+12. What is the difference between the Taxes (in $) in St. Vincent and the Grenadines in 2004 and the Taxes (in $) in Uganda in 2006?
Provide a short and direct response. -2.23e+12. What is the difference between the Taxes (in $) of Malaysia in 2005 and the Taxes (in $) of Sri Lanka in 2006?
Make the answer very short. -3.48e+11. What is the difference between the Taxes (in $) of Malaysia in 2005 and the Taxes (in $) of St. Vincent and the Grenadines in 2006?
Offer a very short reply. 8.02e+1. What is the difference between the Taxes (in $) of Malaysia in 2005 and the Taxes (in $) of Uganda in 2006?
Make the answer very short. -2.15e+12. What is the difference between the Taxes (in $) of Sri Lanka in 2005 and the Taxes (in $) of St. Vincent and the Grenadines in 2006?
Keep it short and to the point. 3.36e+11. What is the difference between the Taxes (in $) of Sri Lanka in 2005 and the Taxes (in $) of Uganda in 2006?
Offer a very short reply. -1.89e+12. What is the difference between the Taxes (in $) in St. Vincent and the Grenadines in 2005 and the Taxes (in $) in Uganda in 2006?
Offer a terse response. -2.23e+12. What is the average Taxes (in $) in Malaysia per year?
Give a very brief answer. 6.56e+1. What is the average Taxes (in $) in Sri Lanka per year?
Your answer should be compact. 2.57e+11. What is the average Taxes (in $) in St. Vincent and the Grenadines per year?
Provide a succinct answer. 2.74e+08. What is the average Taxes (in $) in Uganda per year?
Provide a short and direct response. 1.42e+12. In the year 1999, what is the difference between the Taxes (in $) of Malaysia and Taxes (in $) of Sri Lanka?
Provide a succinct answer. -1.24e+11. In the year 1999, what is the difference between the Taxes (in $) in Malaysia and Taxes (in $) in St. Vincent and the Grenadines?
Ensure brevity in your answer.  4.22e+1. In the year 1999, what is the difference between the Taxes (in $) of Malaysia and Taxes (in $) of Uganda?
Keep it short and to the point. -8.93e+11. In the year 1999, what is the difference between the Taxes (in $) of Sri Lanka and Taxes (in $) of St. Vincent and the Grenadines?
Give a very brief answer. 1.66e+11. In the year 1999, what is the difference between the Taxes (in $) of Sri Lanka and Taxes (in $) of Uganda?
Offer a terse response. -7.70e+11. In the year 1999, what is the difference between the Taxes (in $) of St. Vincent and the Grenadines and Taxes (in $) of Uganda?
Make the answer very short. -9.35e+11. In the year 2000, what is the difference between the Taxes (in $) in Malaysia and Taxes (in $) in Sri Lanka?
Give a very brief answer. -1.34e+11. In the year 2000, what is the difference between the Taxes (in $) of Malaysia and Taxes (in $) of St. Vincent and the Grenadines?
Offer a very short reply. 4.85e+1. In the year 2000, what is the difference between the Taxes (in $) of Malaysia and Taxes (in $) of Uganda?
Ensure brevity in your answer.  -9.29e+11. In the year 2000, what is the difference between the Taxes (in $) in Sri Lanka and Taxes (in $) in St. Vincent and the Grenadines?
Offer a very short reply. 1.82e+11. In the year 2000, what is the difference between the Taxes (in $) in Sri Lanka and Taxes (in $) in Uganda?
Your response must be concise. -7.96e+11. In the year 2000, what is the difference between the Taxes (in $) of St. Vincent and the Grenadines and Taxes (in $) of Uganda?
Offer a terse response. -9.78e+11. In the year 2001, what is the difference between the Taxes (in $) of Malaysia and Taxes (in $) of Sri Lanka?
Keep it short and to the point. -1.43e+11. In the year 2001, what is the difference between the Taxes (in $) of Malaysia and Taxes (in $) of St. Vincent and the Grenadines?
Your answer should be compact. 6.25e+1. In the year 2001, what is the difference between the Taxes (in $) of Malaysia and Taxes (in $) of Uganda?
Your answer should be very brief. -1.01e+12. In the year 2001, what is the difference between the Taxes (in $) of Sri Lanka and Taxes (in $) of St. Vincent and the Grenadines?
Keep it short and to the point. 2.06e+11. In the year 2001, what is the difference between the Taxes (in $) of Sri Lanka and Taxes (in $) of Uganda?
Make the answer very short. -8.69e+11. In the year 2001, what is the difference between the Taxes (in $) in St. Vincent and the Grenadines and Taxes (in $) in Uganda?
Provide a short and direct response. -1.07e+12. In the year 2002, what is the difference between the Taxes (in $) of Malaysia and Taxes (in $) of Sri Lanka?
Give a very brief answer. -1.55e+11. In the year 2002, what is the difference between the Taxes (in $) in Malaysia and Taxes (in $) in St. Vincent and the Grenadines?
Provide a succinct answer. 6.66e+1. In the year 2002, what is the difference between the Taxes (in $) of Malaysia and Taxes (in $) of Uganda?
Your answer should be compact. -1.15e+12. In the year 2002, what is the difference between the Taxes (in $) in Sri Lanka and Taxes (in $) in St. Vincent and the Grenadines?
Offer a terse response. 2.22e+11. In the year 2002, what is the difference between the Taxes (in $) in Sri Lanka and Taxes (in $) in Uganda?
Your answer should be compact. -9.90e+11. In the year 2002, what is the difference between the Taxes (in $) of St. Vincent and the Grenadines and Taxes (in $) of Uganda?
Your response must be concise. -1.21e+12. In the year 2003, what is the difference between the Taxes (in $) in Malaysia and Taxes (in $) in Sri Lanka?
Give a very brief answer. -1.67e+11. In the year 2003, what is the difference between the Taxes (in $) in Malaysia and Taxes (in $) in St. Vincent and the Grenadines?
Provide a short and direct response. 6.46e+1. In the year 2003, what is the difference between the Taxes (in $) of Malaysia and Taxes (in $) of Uganda?
Ensure brevity in your answer.  -1.34e+12. In the year 2003, what is the difference between the Taxes (in $) in Sri Lanka and Taxes (in $) in St. Vincent and the Grenadines?
Keep it short and to the point. 2.31e+11. In the year 2003, what is the difference between the Taxes (in $) of Sri Lanka and Taxes (in $) of Uganda?
Provide a short and direct response. -1.17e+12. In the year 2003, what is the difference between the Taxes (in $) of St. Vincent and the Grenadines and Taxes (in $) of Uganda?
Your answer should be very brief. -1.40e+12. In the year 2004, what is the difference between the Taxes (in $) of Malaysia and Taxes (in $) of Sri Lanka?
Give a very brief answer. -2.10e+11. In the year 2004, what is the difference between the Taxes (in $) in Malaysia and Taxes (in $) in St. Vincent and the Grenadines?
Ensure brevity in your answer.  7.18e+1. In the year 2004, what is the difference between the Taxes (in $) in Malaysia and Taxes (in $) in Uganda?
Offer a very short reply. -1.57e+12. In the year 2004, what is the difference between the Taxes (in $) of Sri Lanka and Taxes (in $) of St. Vincent and the Grenadines?
Provide a succinct answer. 2.81e+11. In the year 2004, what is the difference between the Taxes (in $) in Sri Lanka and Taxes (in $) in Uganda?
Your answer should be compact. -1.36e+12. In the year 2004, what is the difference between the Taxes (in $) of St. Vincent and the Grenadines and Taxes (in $) of Uganda?
Provide a short and direct response. -1.64e+12. In the year 2005, what is the difference between the Taxes (in $) in Malaysia and Taxes (in $) in Sri Lanka?
Provide a short and direct response. -2.56e+11. In the year 2005, what is the difference between the Taxes (in $) of Malaysia and Taxes (in $) of St. Vincent and the Grenadines?
Offer a terse response. 8.03e+1. In the year 2005, what is the difference between the Taxes (in $) in Malaysia and Taxes (in $) in Uganda?
Ensure brevity in your answer.  -1.81e+12. In the year 2005, what is the difference between the Taxes (in $) of Sri Lanka and Taxes (in $) of St. Vincent and the Grenadines?
Keep it short and to the point. 3.37e+11. In the year 2005, what is the difference between the Taxes (in $) of Sri Lanka and Taxes (in $) of Uganda?
Give a very brief answer. -1.55e+12. In the year 2005, what is the difference between the Taxes (in $) in St. Vincent and the Grenadines and Taxes (in $) in Uganda?
Ensure brevity in your answer.  -1.89e+12. In the year 2006, what is the difference between the Taxes (in $) in Malaysia and Taxes (in $) in Sri Lanka?
Provide a short and direct response. -3.42e+11. In the year 2006, what is the difference between the Taxes (in $) of Malaysia and Taxes (in $) of St. Vincent and the Grenadines?
Make the answer very short. 8.63e+1. In the year 2006, what is the difference between the Taxes (in $) in Malaysia and Taxes (in $) in Uganda?
Give a very brief answer. -2.14e+12. In the year 2006, what is the difference between the Taxes (in $) in Sri Lanka and Taxes (in $) in St. Vincent and the Grenadines?
Offer a terse response. 4.28e+11. In the year 2006, what is the difference between the Taxes (in $) in Sri Lanka and Taxes (in $) in Uganda?
Make the answer very short. -1.80e+12. In the year 2006, what is the difference between the Taxes (in $) in St. Vincent and the Grenadines and Taxes (in $) in Uganda?
Offer a terse response. -2.23e+12. What is the ratio of the Taxes (in $) in Malaysia in 1999 to that in 2000?
Provide a succinct answer. 0.87. What is the ratio of the Taxes (in $) in Sri Lanka in 1999 to that in 2000?
Make the answer very short. 0.91. What is the ratio of the Taxes (in $) in St. Vincent and the Grenadines in 1999 to that in 2000?
Offer a very short reply. 0.96. What is the ratio of the Taxes (in $) of Uganda in 1999 to that in 2000?
Your response must be concise. 0.96. What is the ratio of the Taxes (in $) of Malaysia in 1999 to that in 2001?
Your response must be concise. 0.68. What is the ratio of the Taxes (in $) in Sri Lanka in 1999 to that in 2001?
Make the answer very short. 0.81. What is the ratio of the Taxes (in $) of St. Vincent and the Grenadines in 1999 to that in 2001?
Offer a very short reply. 0.9. What is the ratio of the Taxes (in $) of Uganda in 1999 to that in 2001?
Your answer should be very brief. 0.87. What is the ratio of the Taxes (in $) in Malaysia in 1999 to that in 2002?
Give a very brief answer. 0.63. What is the ratio of the Taxes (in $) in Sri Lanka in 1999 to that in 2002?
Offer a very short reply. 0.75. What is the ratio of the Taxes (in $) in St. Vincent and the Grenadines in 1999 to that in 2002?
Your answer should be compact. 0.8. What is the ratio of the Taxes (in $) in Uganda in 1999 to that in 2002?
Your answer should be very brief. 0.77. What is the ratio of the Taxes (in $) in Malaysia in 1999 to that in 2003?
Ensure brevity in your answer.  0.65. What is the ratio of the Taxes (in $) in Sri Lanka in 1999 to that in 2003?
Provide a short and direct response. 0.72. What is the ratio of the Taxes (in $) in St. Vincent and the Grenadines in 1999 to that in 2003?
Provide a short and direct response. 0.8. What is the ratio of the Taxes (in $) of Uganda in 1999 to that in 2003?
Give a very brief answer. 0.67. What is the ratio of the Taxes (in $) in Malaysia in 1999 to that in 2004?
Your answer should be compact. 0.59. What is the ratio of the Taxes (in $) of Sri Lanka in 1999 to that in 2004?
Your answer should be very brief. 0.59. What is the ratio of the Taxes (in $) in St. Vincent and the Grenadines in 1999 to that in 2004?
Ensure brevity in your answer.  0.75. What is the ratio of the Taxes (in $) in Uganda in 1999 to that in 2004?
Ensure brevity in your answer.  0.57. What is the ratio of the Taxes (in $) of Malaysia in 1999 to that in 2005?
Keep it short and to the point. 0.53. What is the ratio of the Taxes (in $) of Sri Lanka in 1999 to that in 2005?
Your response must be concise. 0.49. What is the ratio of the Taxes (in $) of St. Vincent and the Grenadines in 1999 to that in 2005?
Your response must be concise. 0.71. What is the ratio of the Taxes (in $) in Uganda in 1999 to that in 2005?
Offer a very short reply. 0.5. What is the ratio of the Taxes (in $) of Malaysia in 1999 to that in 2006?
Keep it short and to the point. 0.49. What is the ratio of the Taxes (in $) in Sri Lanka in 1999 to that in 2006?
Offer a very short reply. 0.39. What is the ratio of the Taxes (in $) of St. Vincent and the Grenadines in 1999 to that in 2006?
Your answer should be very brief. 0.6. What is the ratio of the Taxes (in $) of Uganda in 1999 to that in 2006?
Offer a terse response. 0.42. What is the ratio of the Taxes (in $) of Malaysia in 2000 to that in 2001?
Your answer should be very brief. 0.78. What is the ratio of the Taxes (in $) of Sri Lanka in 2000 to that in 2001?
Ensure brevity in your answer.  0.89. What is the ratio of the Taxes (in $) in St. Vincent and the Grenadines in 2000 to that in 2001?
Provide a short and direct response. 0.94. What is the ratio of the Taxes (in $) of Uganda in 2000 to that in 2001?
Provide a short and direct response. 0.91. What is the ratio of the Taxes (in $) of Malaysia in 2000 to that in 2002?
Give a very brief answer. 0.73. What is the ratio of the Taxes (in $) of Sri Lanka in 2000 to that in 2002?
Offer a very short reply. 0.82. What is the ratio of the Taxes (in $) of St. Vincent and the Grenadines in 2000 to that in 2002?
Keep it short and to the point. 0.83. What is the ratio of the Taxes (in $) in Uganda in 2000 to that in 2002?
Give a very brief answer. 0.81. What is the ratio of the Taxes (in $) in Malaysia in 2000 to that in 2003?
Ensure brevity in your answer.  0.75. What is the ratio of the Taxes (in $) in Sri Lanka in 2000 to that in 2003?
Give a very brief answer. 0.79. What is the ratio of the Taxes (in $) in St. Vincent and the Grenadines in 2000 to that in 2003?
Offer a terse response. 0.84. What is the ratio of the Taxes (in $) in Uganda in 2000 to that in 2003?
Keep it short and to the point. 0.7. What is the ratio of the Taxes (in $) in Malaysia in 2000 to that in 2004?
Offer a terse response. 0.68. What is the ratio of the Taxes (in $) of Sri Lanka in 2000 to that in 2004?
Give a very brief answer. 0.65. What is the ratio of the Taxes (in $) of St. Vincent and the Grenadines in 2000 to that in 2004?
Offer a terse response. 0.78. What is the ratio of the Taxes (in $) of Uganda in 2000 to that in 2004?
Ensure brevity in your answer.  0.6. What is the ratio of the Taxes (in $) in Malaysia in 2000 to that in 2005?
Offer a very short reply. 0.6. What is the ratio of the Taxes (in $) in Sri Lanka in 2000 to that in 2005?
Give a very brief answer. 0.54. What is the ratio of the Taxes (in $) of St. Vincent and the Grenadines in 2000 to that in 2005?
Provide a short and direct response. 0.75. What is the ratio of the Taxes (in $) of Uganda in 2000 to that in 2005?
Make the answer very short. 0.52. What is the ratio of the Taxes (in $) of Malaysia in 2000 to that in 2006?
Offer a very short reply. 0.56. What is the ratio of the Taxes (in $) in Sri Lanka in 2000 to that in 2006?
Keep it short and to the point. 0.43. What is the ratio of the Taxes (in $) of St. Vincent and the Grenadines in 2000 to that in 2006?
Ensure brevity in your answer.  0.63. What is the ratio of the Taxes (in $) in Uganda in 2000 to that in 2006?
Keep it short and to the point. 0.44. What is the ratio of the Taxes (in $) of Malaysia in 2001 to that in 2002?
Your answer should be compact. 0.94. What is the ratio of the Taxes (in $) of Sri Lanka in 2001 to that in 2002?
Offer a very short reply. 0.93. What is the ratio of the Taxes (in $) of St. Vincent and the Grenadines in 2001 to that in 2002?
Ensure brevity in your answer.  0.89. What is the ratio of the Taxes (in $) of Uganda in 2001 to that in 2002?
Ensure brevity in your answer.  0.89. What is the ratio of the Taxes (in $) in Malaysia in 2001 to that in 2003?
Keep it short and to the point. 0.97. What is the ratio of the Taxes (in $) of Sri Lanka in 2001 to that in 2003?
Keep it short and to the point. 0.89. What is the ratio of the Taxes (in $) of St. Vincent and the Grenadines in 2001 to that in 2003?
Your answer should be very brief. 0.89. What is the ratio of the Taxes (in $) in Uganda in 2001 to that in 2003?
Offer a terse response. 0.77. What is the ratio of the Taxes (in $) in Malaysia in 2001 to that in 2004?
Offer a terse response. 0.87. What is the ratio of the Taxes (in $) in Sri Lanka in 2001 to that in 2004?
Provide a succinct answer. 0.73. What is the ratio of the Taxes (in $) of St. Vincent and the Grenadines in 2001 to that in 2004?
Your response must be concise. 0.83. What is the ratio of the Taxes (in $) in Uganda in 2001 to that in 2004?
Make the answer very short. 0.65. What is the ratio of the Taxes (in $) in Malaysia in 2001 to that in 2005?
Offer a terse response. 0.78. What is the ratio of the Taxes (in $) of Sri Lanka in 2001 to that in 2005?
Provide a succinct answer. 0.61. What is the ratio of the Taxes (in $) in St. Vincent and the Grenadines in 2001 to that in 2005?
Keep it short and to the point. 0.79. What is the ratio of the Taxes (in $) of Uganda in 2001 to that in 2005?
Your answer should be very brief. 0.57. What is the ratio of the Taxes (in $) of Malaysia in 2001 to that in 2006?
Offer a terse response. 0.72. What is the ratio of the Taxes (in $) in Sri Lanka in 2001 to that in 2006?
Provide a short and direct response. 0.48. What is the ratio of the Taxes (in $) of St. Vincent and the Grenadines in 2001 to that in 2006?
Offer a terse response. 0.67. What is the ratio of the Taxes (in $) of Uganda in 2001 to that in 2006?
Provide a succinct answer. 0.48. What is the ratio of the Taxes (in $) of Malaysia in 2002 to that in 2003?
Give a very brief answer. 1.03. What is the ratio of the Taxes (in $) in Sri Lanka in 2002 to that in 2003?
Your answer should be compact. 0.96. What is the ratio of the Taxes (in $) of Uganda in 2002 to that in 2003?
Provide a succinct answer. 0.86. What is the ratio of the Taxes (in $) in Malaysia in 2002 to that in 2004?
Keep it short and to the point. 0.93. What is the ratio of the Taxes (in $) of Sri Lanka in 2002 to that in 2004?
Offer a very short reply. 0.79. What is the ratio of the Taxes (in $) of St. Vincent and the Grenadines in 2002 to that in 2004?
Offer a very short reply. 0.94. What is the ratio of the Taxes (in $) of Uganda in 2002 to that in 2004?
Make the answer very short. 0.74. What is the ratio of the Taxes (in $) of Malaysia in 2002 to that in 2005?
Your response must be concise. 0.83. What is the ratio of the Taxes (in $) of Sri Lanka in 2002 to that in 2005?
Give a very brief answer. 0.66. What is the ratio of the Taxes (in $) of St. Vincent and the Grenadines in 2002 to that in 2005?
Keep it short and to the point. 0.89. What is the ratio of the Taxes (in $) in Uganda in 2002 to that in 2005?
Your response must be concise. 0.64. What is the ratio of the Taxes (in $) in Malaysia in 2002 to that in 2006?
Provide a succinct answer. 0.77. What is the ratio of the Taxes (in $) in Sri Lanka in 2002 to that in 2006?
Keep it short and to the point. 0.52. What is the ratio of the Taxes (in $) of St. Vincent and the Grenadines in 2002 to that in 2006?
Your answer should be very brief. 0.75. What is the ratio of the Taxes (in $) in Uganda in 2002 to that in 2006?
Offer a terse response. 0.54. What is the ratio of the Taxes (in $) in Malaysia in 2003 to that in 2004?
Your answer should be very brief. 0.9. What is the ratio of the Taxes (in $) of Sri Lanka in 2003 to that in 2004?
Offer a terse response. 0.82. What is the ratio of the Taxes (in $) in St. Vincent and the Grenadines in 2003 to that in 2004?
Ensure brevity in your answer.  0.94. What is the ratio of the Taxes (in $) in Uganda in 2003 to that in 2004?
Offer a terse response. 0.85. What is the ratio of the Taxes (in $) in Malaysia in 2003 to that in 2005?
Make the answer very short. 0.81. What is the ratio of the Taxes (in $) in Sri Lanka in 2003 to that in 2005?
Ensure brevity in your answer.  0.69. What is the ratio of the Taxes (in $) of St. Vincent and the Grenadines in 2003 to that in 2005?
Provide a short and direct response. 0.89. What is the ratio of the Taxes (in $) of Uganda in 2003 to that in 2005?
Provide a short and direct response. 0.74. What is the ratio of the Taxes (in $) in Malaysia in 2003 to that in 2006?
Make the answer very short. 0.75. What is the ratio of the Taxes (in $) of Sri Lanka in 2003 to that in 2006?
Offer a terse response. 0.54. What is the ratio of the Taxes (in $) of St. Vincent and the Grenadines in 2003 to that in 2006?
Your answer should be very brief. 0.75. What is the ratio of the Taxes (in $) in Uganda in 2003 to that in 2006?
Your answer should be compact. 0.63. What is the ratio of the Taxes (in $) in Malaysia in 2004 to that in 2005?
Your answer should be very brief. 0.89. What is the ratio of the Taxes (in $) of Sri Lanka in 2004 to that in 2005?
Your answer should be very brief. 0.84. What is the ratio of the Taxes (in $) of St. Vincent and the Grenadines in 2004 to that in 2005?
Your answer should be compact. 0.95. What is the ratio of the Taxes (in $) in Uganda in 2004 to that in 2005?
Give a very brief answer. 0.87. What is the ratio of the Taxes (in $) in Malaysia in 2004 to that in 2006?
Your answer should be compact. 0.83. What is the ratio of the Taxes (in $) in Sri Lanka in 2004 to that in 2006?
Give a very brief answer. 0.66. What is the ratio of the Taxes (in $) in St. Vincent and the Grenadines in 2004 to that in 2006?
Give a very brief answer. 0.8. What is the ratio of the Taxes (in $) of Uganda in 2004 to that in 2006?
Offer a very short reply. 0.74. What is the ratio of the Taxes (in $) of Malaysia in 2005 to that in 2006?
Your response must be concise. 0.93. What is the ratio of the Taxes (in $) in Sri Lanka in 2005 to that in 2006?
Offer a very short reply. 0.79. What is the ratio of the Taxes (in $) in St. Vincent and the Grenadines in 2005 to that in 2006?
Your answer should be compact. 0.84. What is the ratio of the Taxes (in $) of Uganda in 2005 to that in 2006?
Provide a succinct answer. 0.85. What is the difference between the highest and the second highest Taxes (in $) of Malaysia?
Your answer should be very brief. 6.04e+09. What is the difference between the highest and the second highest Taxes (in $) of Sri Lanka?
Your answer should be compact. 9.16e+1. What is the difference between the highest and the second highest Taxes (in $) of St. Vincent and the Grenadines?
Give a very brief answer. 5.75e+07. What is the difference between the highest and the second highest Taxes (in $) in Uganda?
Keep it short and to the point. 3.44e+11. What is the difference between the highest and the lowest Taxes (in $) of Malaysia?
Provide a succinct answer. 4.42e+1. What is the difference between the highest and the lowest Taxes (in $) in Sri Lanka?
Provide a short and direct response. 2.62e+11. What is the difference between the highest and the lowest Taxes (in $) in St. Vincent and the Grenadines?
Provide a short and direct response. 1.44e+08. What is the difference between the highest and the lowest Taxes (in $) of Uganda?
Provide a short and direct response. 1.30e+12. 